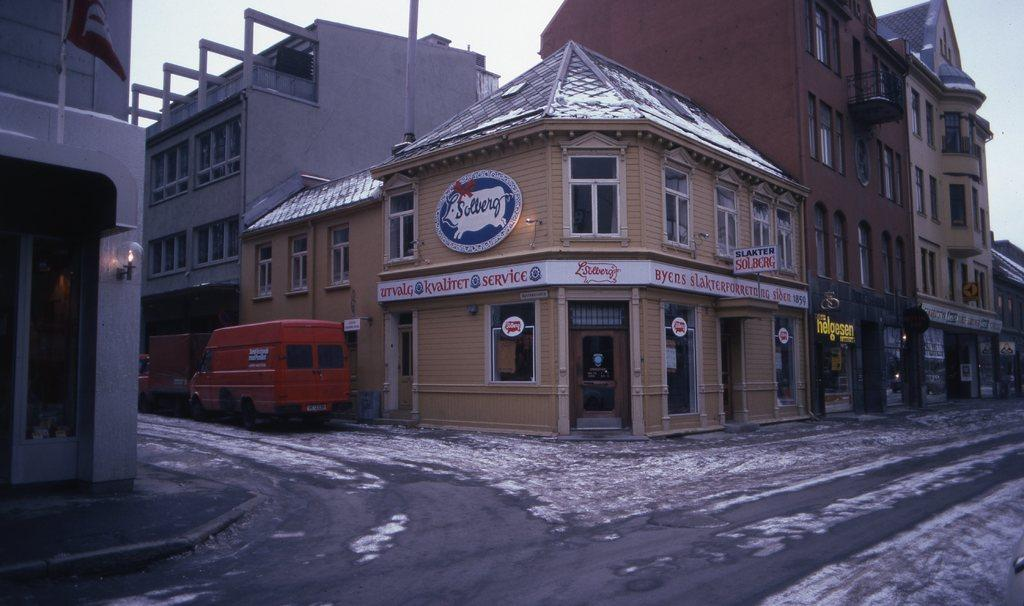What type of structures can be seen in the image? There are buildings in the image. What else is visible on the ground in the image? Vehicles are present on the road in the image. Can you describe a specific feature of one of the buildings? There is a light attached to a building. What are the boards attached to the buildings used for? The boards attached to the buildings might be used for advertisements or announcements. What can be seen in the background of the image? The sky is visible in the background of the image. What type of prose is written on the chalkboard in the image? There is no chalkboard present in the image, and therefore no prose can be observed. How does the regret of the driver affect the traffic in the image? There is no indication of regret or any emotional state of the driver in the image, and therefore it cannot be determined how it affects the traffic. 